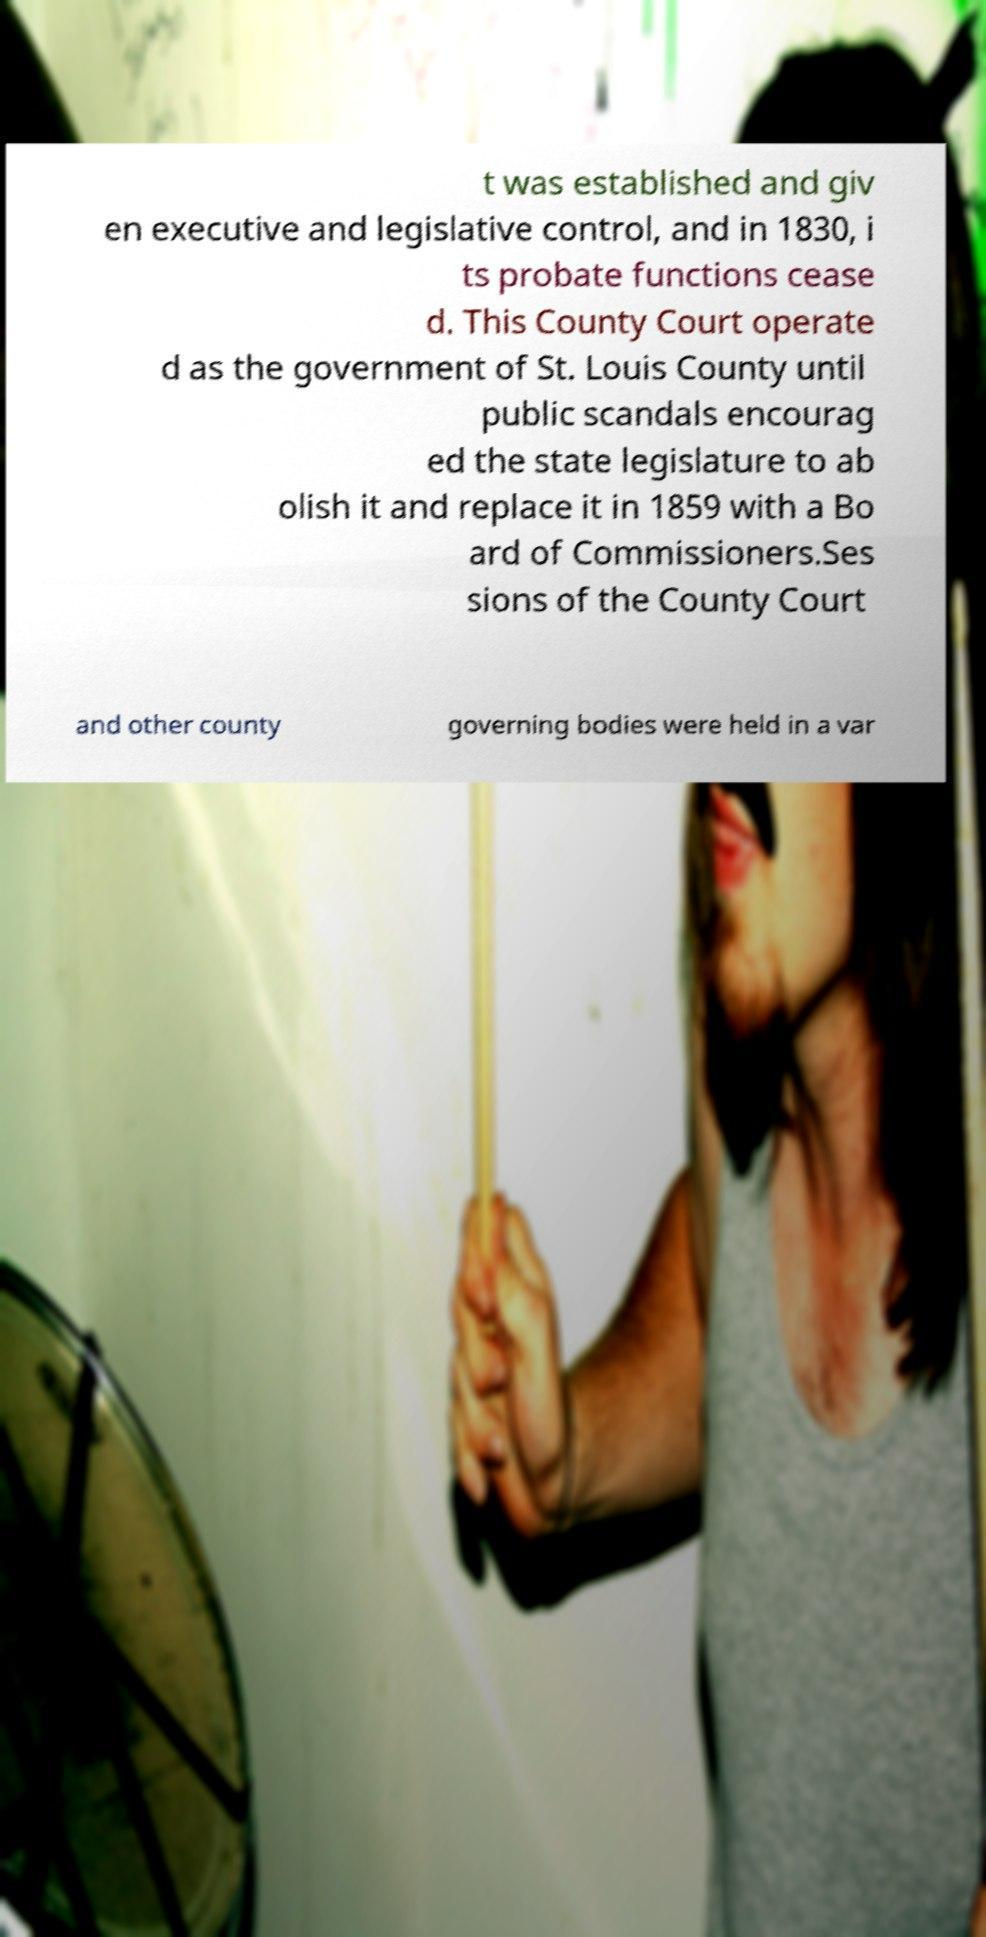Please read and relay the text visible in this image. What does it say? t was established and giv en executive and legislative control, and in 1830, i ts probate functions cease d. This County Court operate d as the government of St. Louis County until public scandals encourag ed the state legislature to ab olish it and replace it in 1859 with a Bo ard of Commissioners.Ses sions of the County Court and other county governing bodies were held in a var 